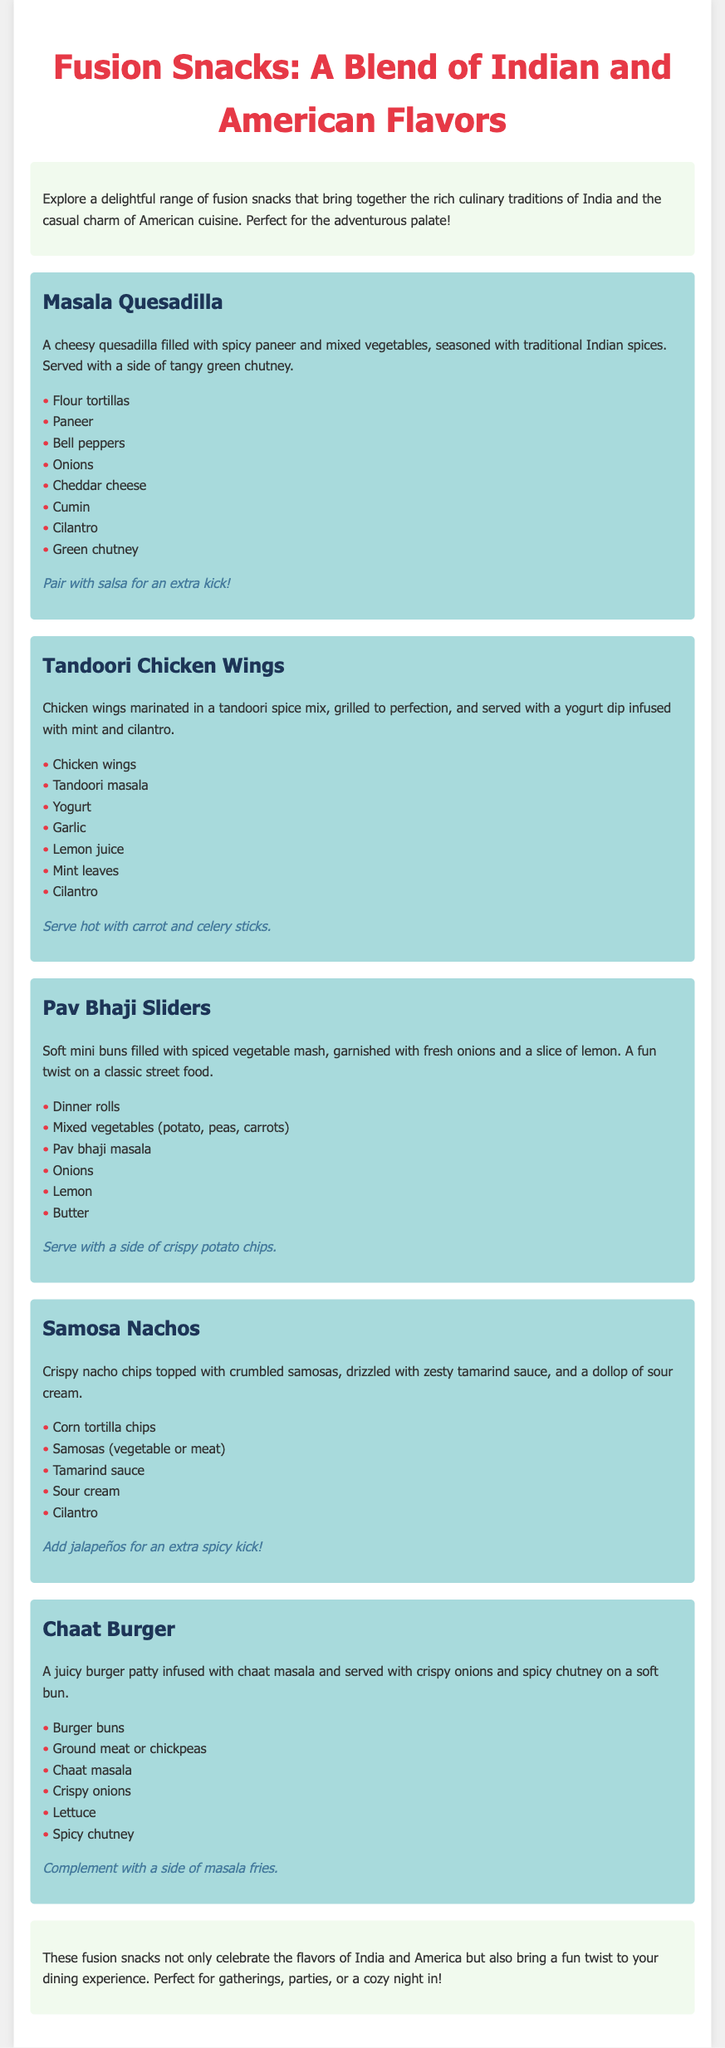What is the first fusion snack listed? The first fusion snack mentioned in the document is the Masala Quesadilla.
Answer: Masala Quesadilla What ingredient is used in Tandoori Chicken Wings? Tandoori Chicken Wings include tandoori masala as one of their ingredients.
Answer: Tandoori masala What is served with Pav Bhaji Sliders? Pav Bhaji Sliders are suggested to be served with a side of crispy potato chips.
Answer: Crispy potato chips How many main ingredients are listed for Samosa Nachos? There are five main ingredients listed for Samosa Nachos in the document.
Answer: Five What is the color of the subtitle text for each snack? The subtitle text for each snack is colored in a shade of dark blue.
Answer: Dark blue What type of bun is used in the Chaat Burger? The Chaat Burger is served on a burger bun.
Answer: Burger buns How is the serving suggestion for Masala Quesadilla described? The serving suggestion for Masala Quesadilla is to pair it with salsa for an extra kick.
Answer: Pair with salsa What is the main purpose of the document? The document aims to explore fusion snacks that combine Indian and American culinary traditions.
Answer: Explore fusion snacks 